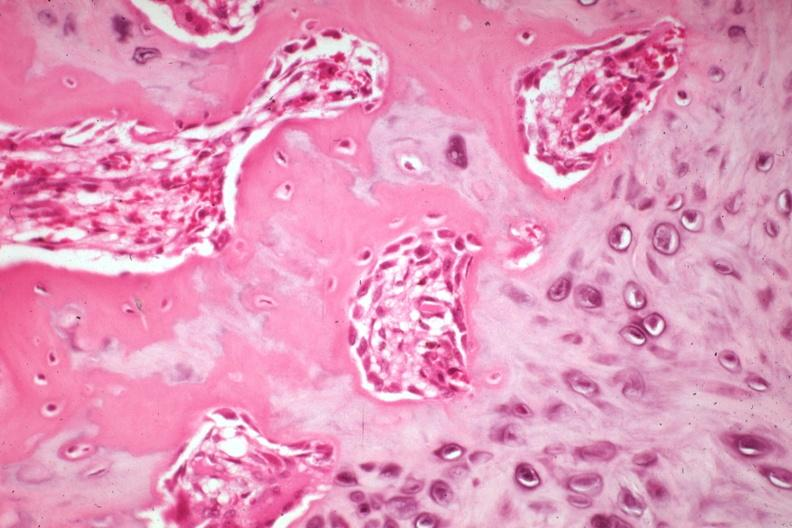how does this image show high osteoid deposition?
Answer the question using a single word or phrase. With new bone formation and osteoblasts also cartilage excellent example case is a non-union 